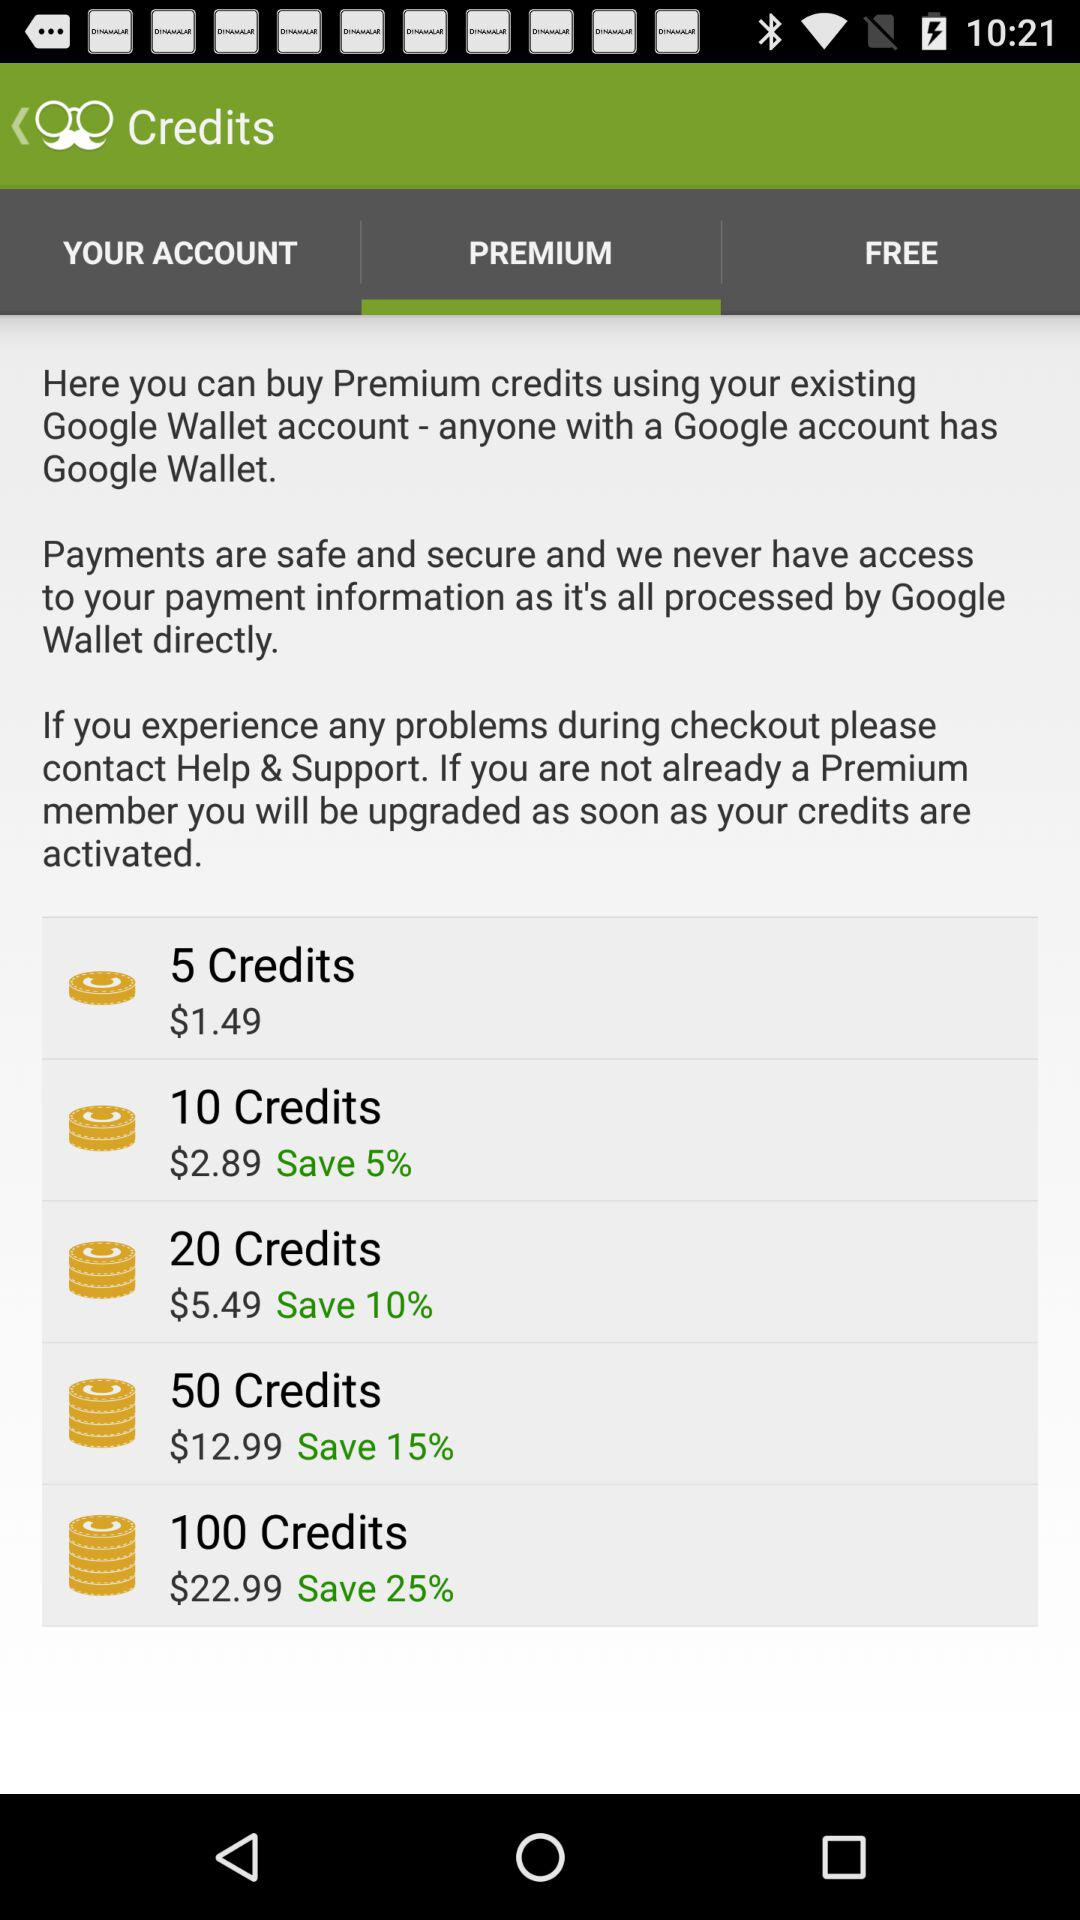What percentage is saved in 100 credits? In 100 credits, the percentage saved is 25. 